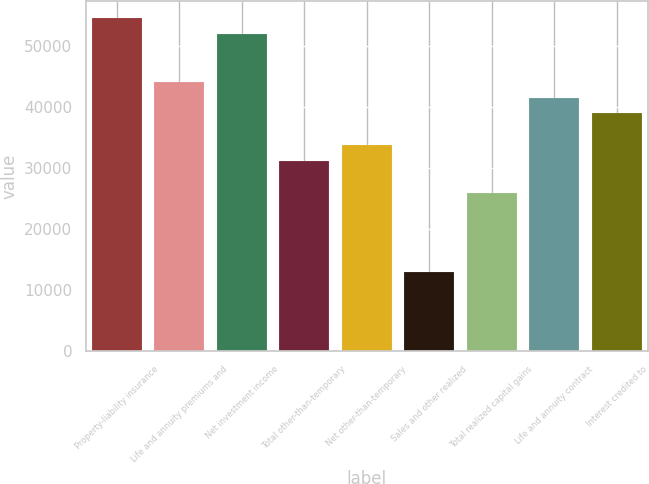Convert chart. <chart><loc_0><loc_0><loc_500><loc_500><bar_chart><fcel>Property-liability insurance<fcel>Life and annuity premiums and<fcel>Net investment income<fcel>Total other-than-temporary<fcel>Net other-than-temporary<fcel>Sales and other realized<fcel>Total realized capital gains<fcel>Life and annuity contract<fcel>Interest credited to<nl><fcel>54508.8<fcel>44126.3<fcel>51913.2<fcel>31148.2<fcel>33743.9<fcel>12978.9<fcel>25957<fcel>41530.7<fcel>38935.1<nl></chart> 